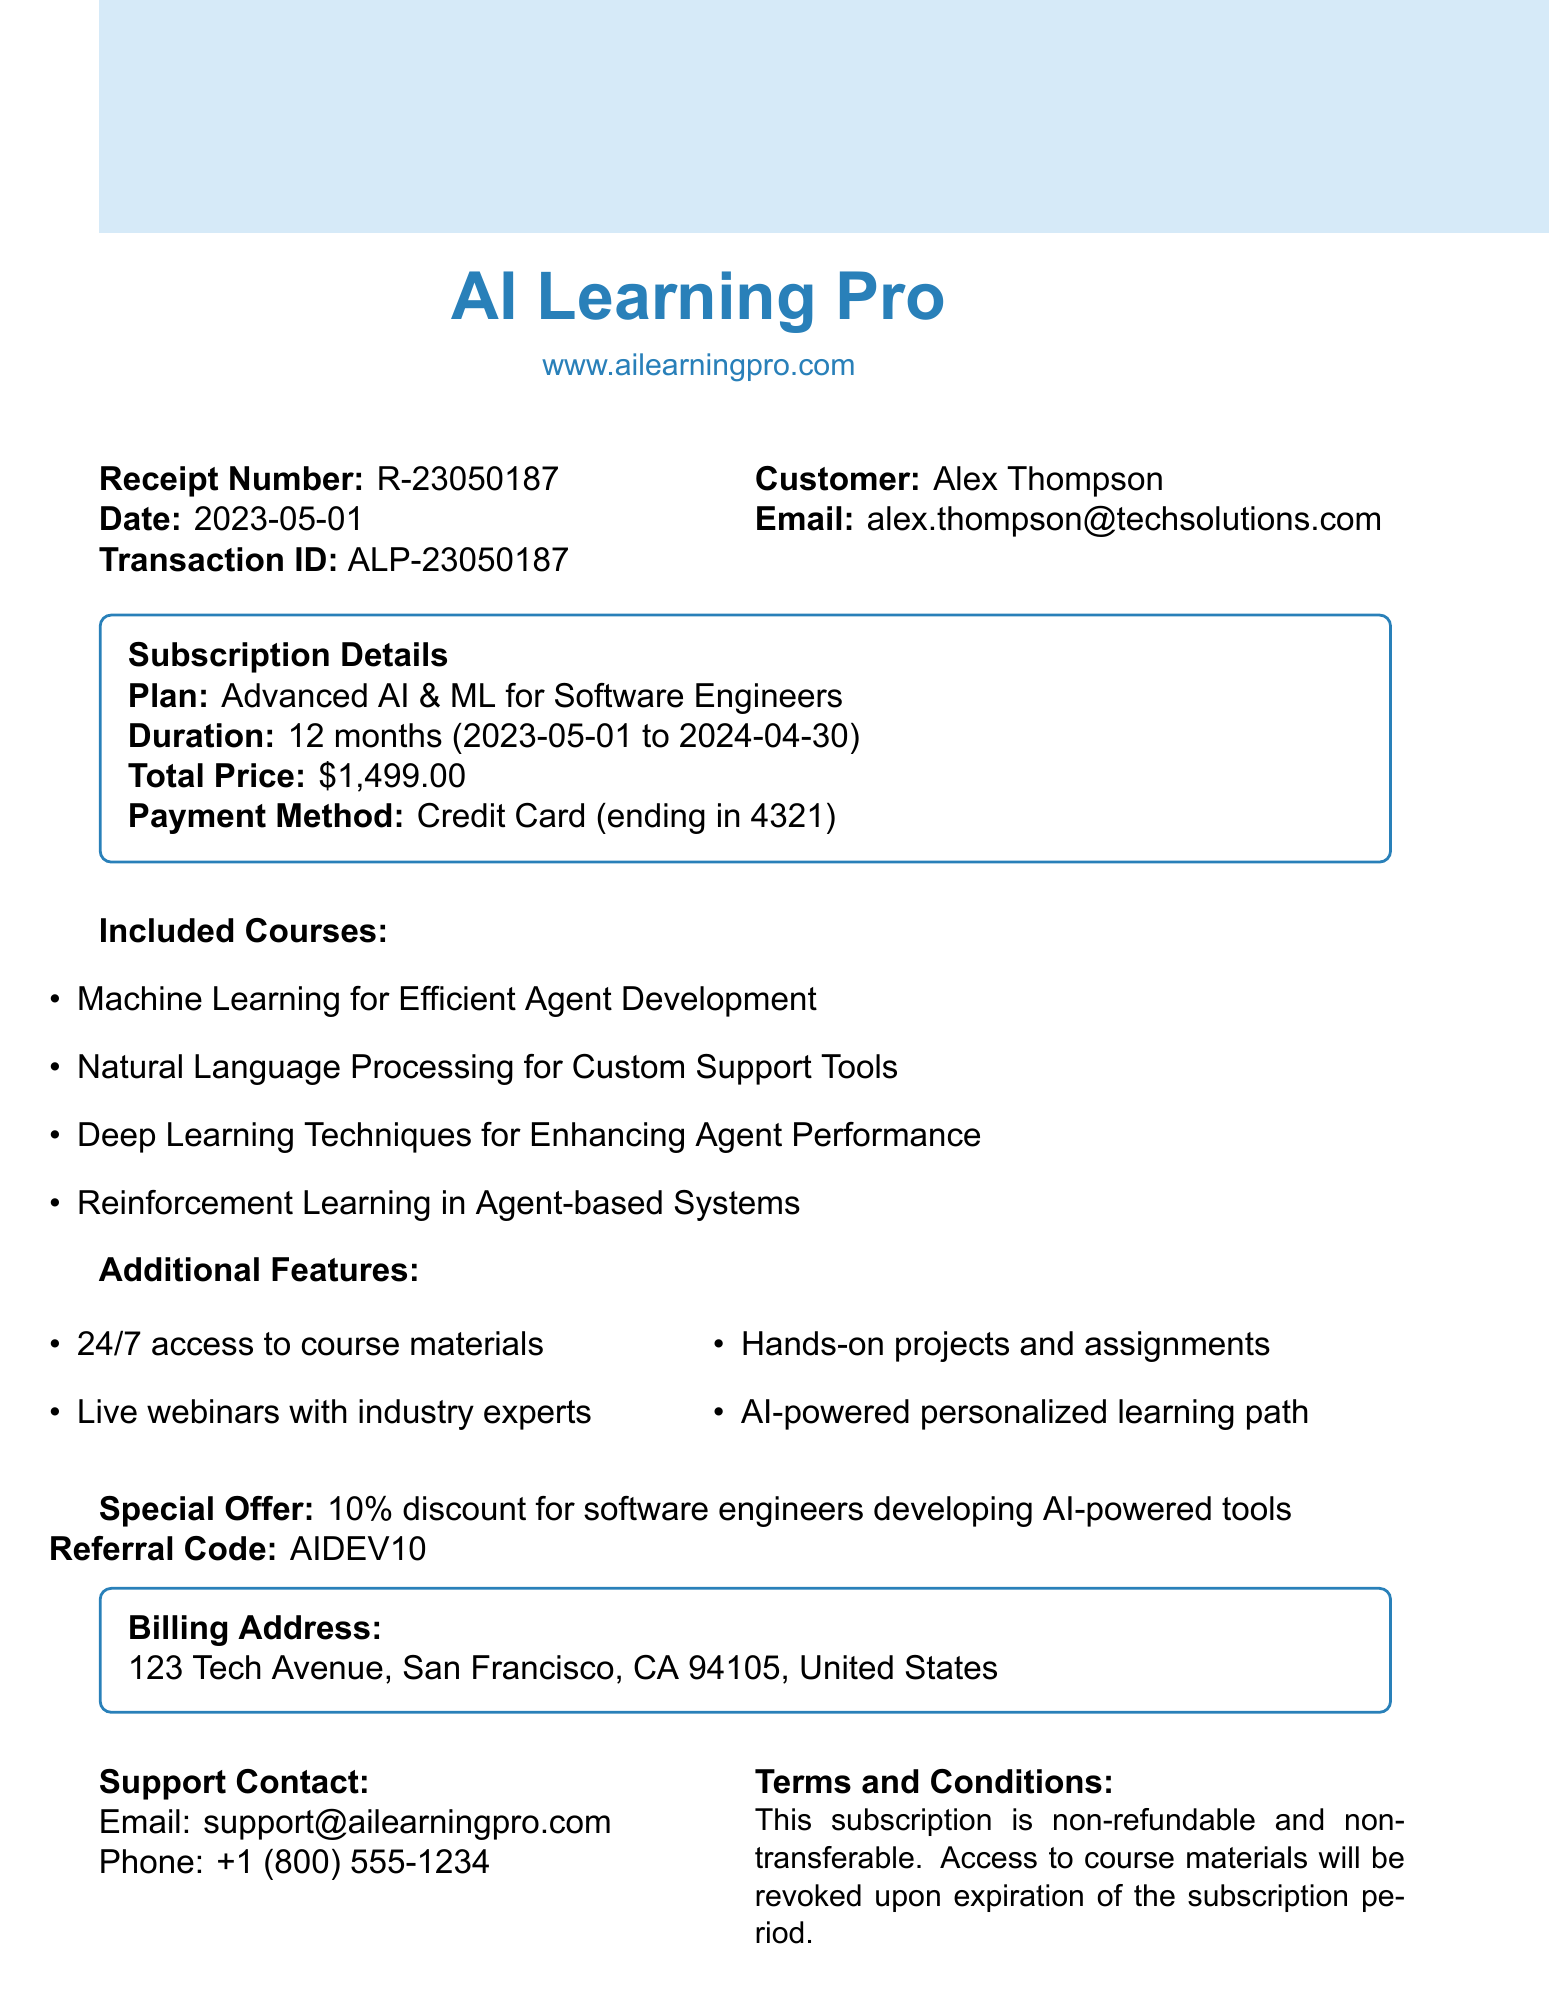What is the name of the company? The name of the company providing the subscription, as stated in the document, is AI Learning Pro.
Answer: AI Learning Pro What is the total price of the subscription? The total price of the subscription is explicitly stated in the document.
Answer: $1,499.00 What is the customer's email address? The customer's email address is provided under the customer information section of the document.
Answer: alex.thompson@techsolutions.com When does the subscription end? The end date of the subscription is provided in the subscription details section.
Answer: 2024-04-30 What special offer is mentioned in the document? The document mentions a specific offer that is directed towards a certain group, which is noted in the special offer section.
Answer: 10% discount for software engineers developing AI-powered tools How many courses are included in the subscription? The document lists the included courses, and the total number can be counted from that list.
Answer: 4 What is the referral code? The referral code is specifically stated in the document under the special offer section.
Answer: AIDEV10 What are the payment method details? The document provides the payment method, specifically mentioning how it's paid and the last four digits of the card.
Answer: Credit Card (ending in 4321) What is the billing address listed in the document? The billing address is provided in a dedicated section and includes complete details about the address.
Answer: 123 Tech Avenue, San Francisco, CA 94105, United States 